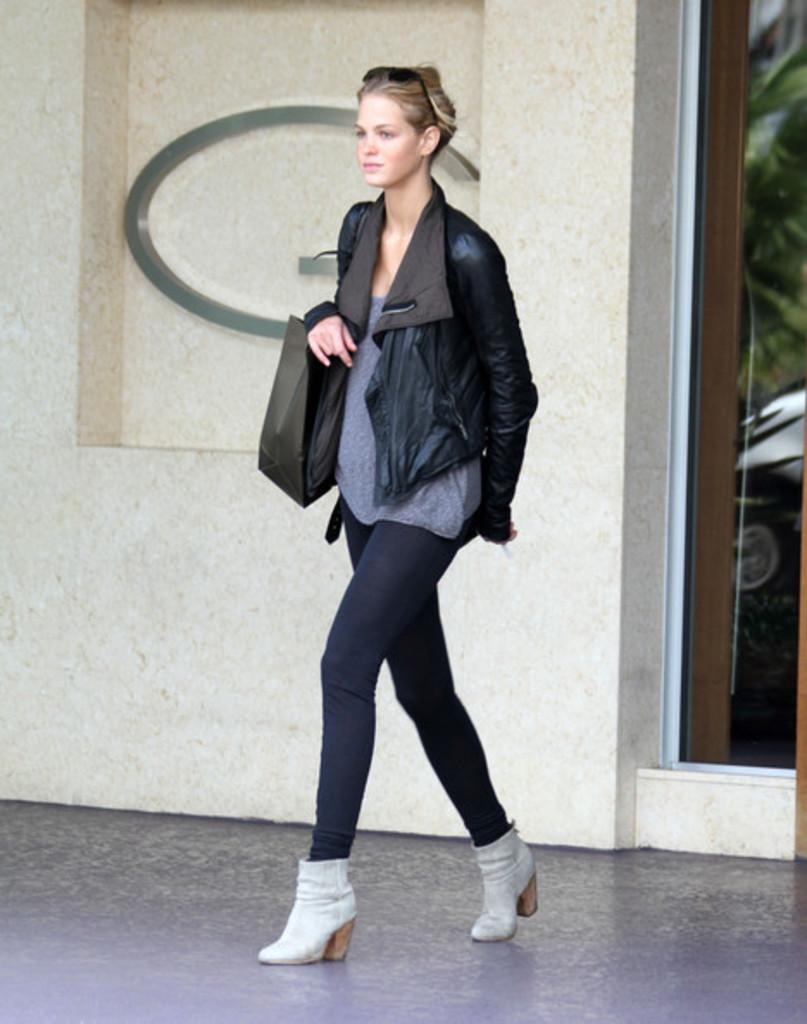In one or two sentences, can you explain what this image depicts? In this image a girl wearing black color jacket and holding a black bag on her right hand. and back side of her there is a wall and there a metal attached to the wall. 